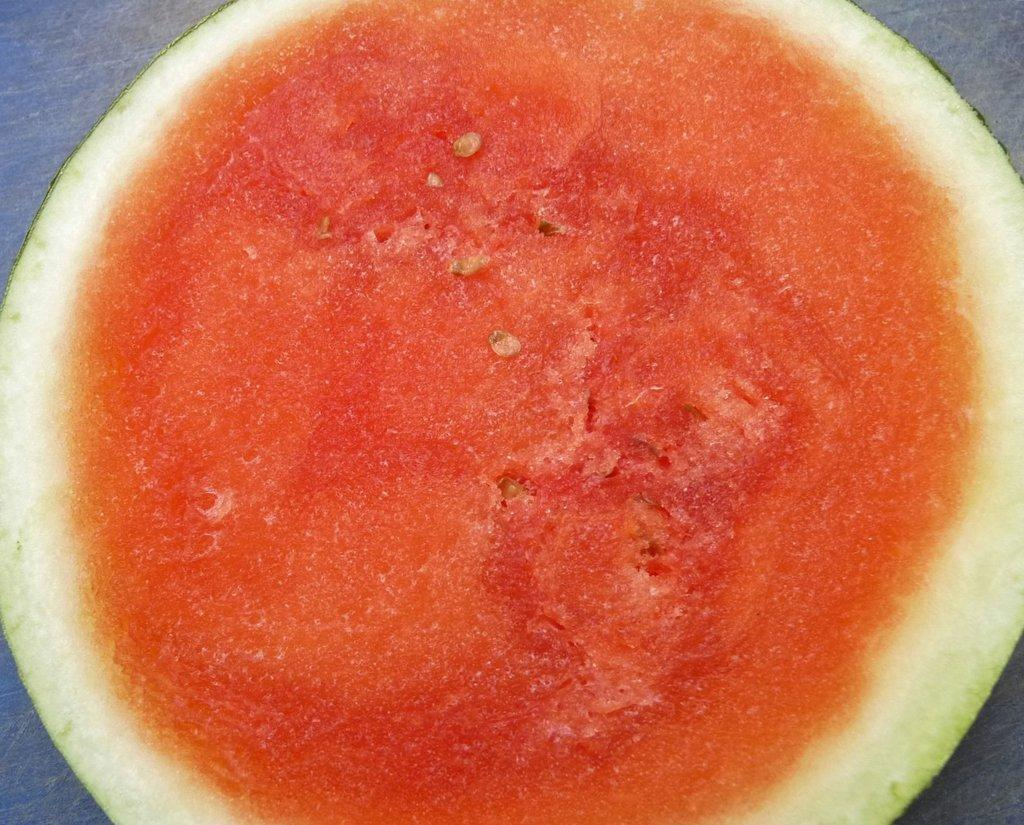What type of fruit is present in the image? There is a piece of watermelon in the image. What type of vegetable is being shown in the image? There is no vegetable present in the image; it features a piece of watermelon, which is a fruit. What type of wool is visible in the image? There is no wool present in the image. 